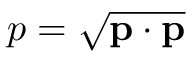<formula> <loc_0><loc_0><loc_500><loc_500>p = { \sqrt { p \cdot p } }</formula> 